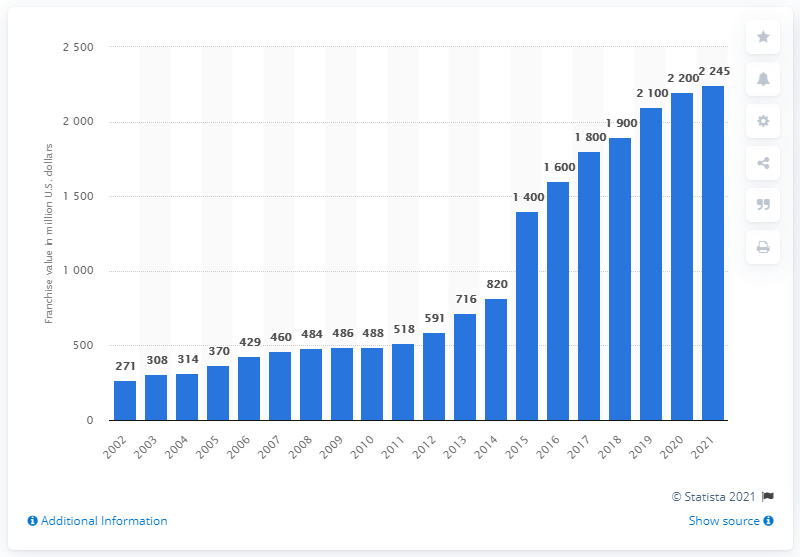Give some essential details in this illustration. The estimated value of the St. Louis Cardinals in 2021 was 2,245. 